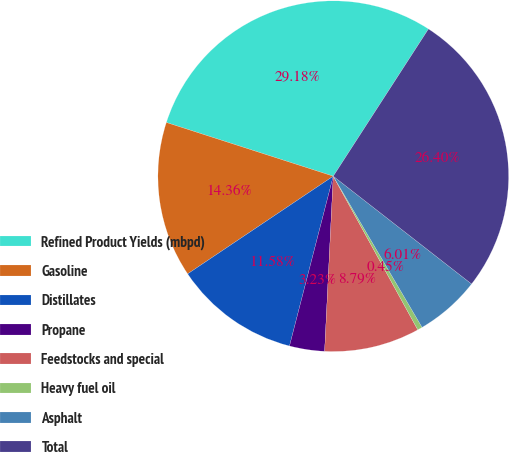Convert chart to OTSL. <chart><loc_0><loc_0><loc_500><loc_500><pie_chart><fcel>Refined Product Yields (mbpd)<fcel>Gasoline<fcel>Distillates<fcel>Propane<fcel>Feedstocks and special<fcel>Heavy fuel oil<fcel>Asphalt<fcel>Total<nl><fcel>29.18%<fcel>14.36%<fcel>11.58%<fcel>3.23%<fcel>8.79%<fcel>0.45%<fcel>6.01%<fcel>26.4%<nl></chart> 